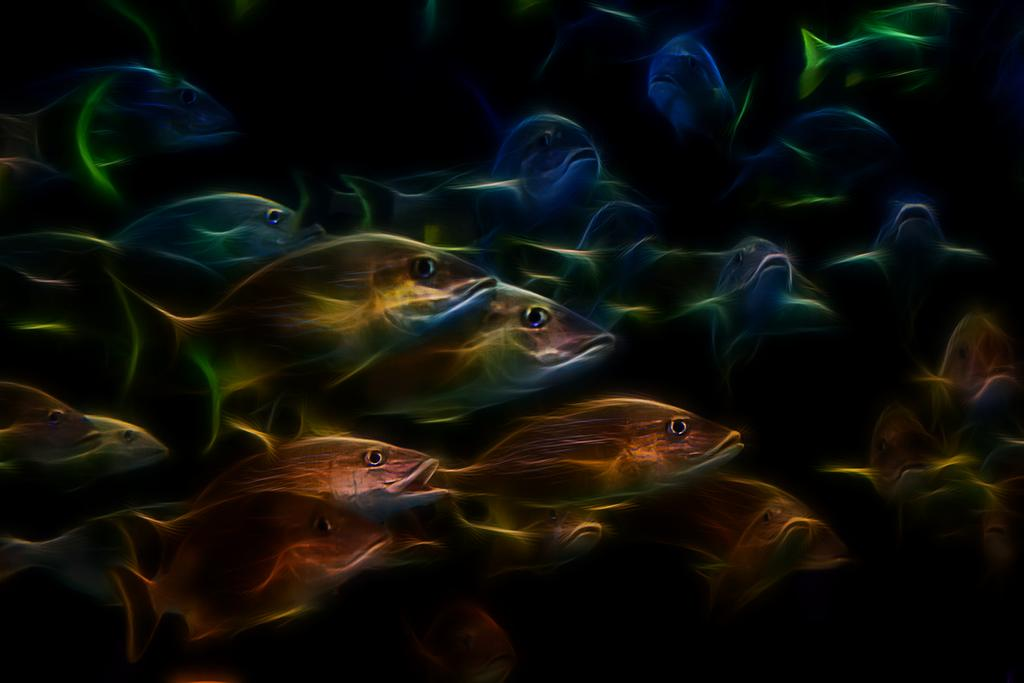What type of animals can be seen in the image? There is a group of fishes in the image. What type of trousers are the fishes wearing in the image? Fishes do not wear trousers, as they are aquatic animals without the ability to wear clothing. 